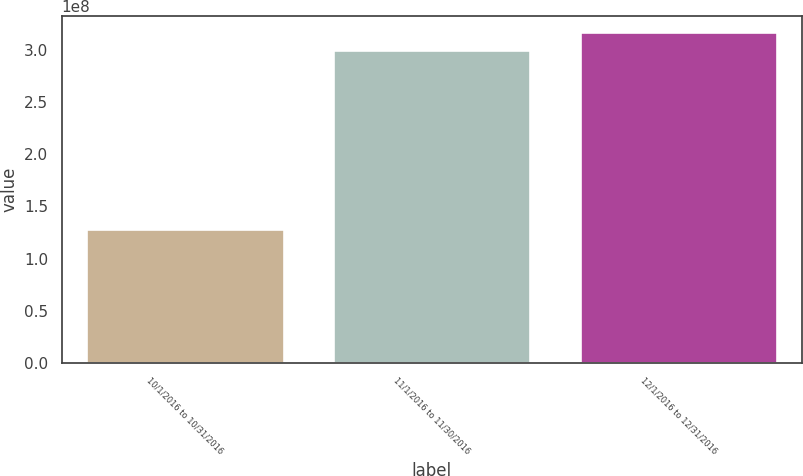Convert chart to OTSL. <chart><loc_0><loc_0><loc_500><loc_500><bar_chart><fcel>10/1/2016 to 10/31/2016<fcel>11/1/2016 to 11/30/2016<fcel>12/1/2016 to 12/31/2016<nl><fcel>1.28353e+08<fcel>3e+08<fcel>3.17165e+08<nl></chart> 